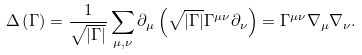<formula> <loc_0><loc_0><loc_500><loc_500>\Delta \left ( \Gamma \right ) = \frac { 1 } { \sqrt { | \Gamma | } } \sum _ { \mu , \nu } \partial _ { \mu } \left ( \sqrt { | \Gamma | } \Gamma ^ { \mu \nu } \partial _ { \nu } \right ) = \Gamma ^ { \mu \nu } \nabla _ { \mu } \nabla _ { \nu } .</formula> 